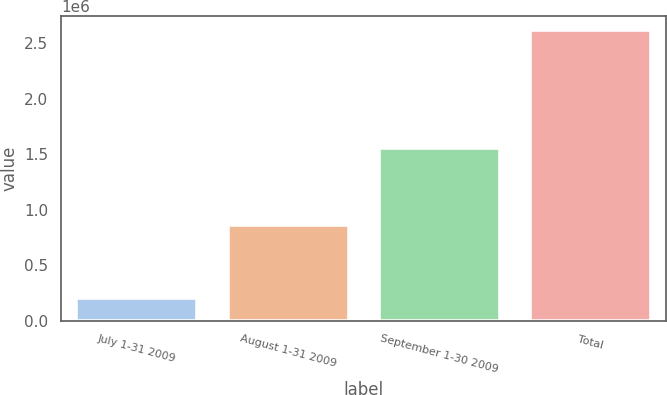<chart> <loc_0><loc_0><loc_500><loc_500><bar_chart><fcel>July 1-31 2009<fcel>August 1-31 2009<fcel>September 1-30 2009<fcel>Total<nl><fcel>200594<fcel>864012<fcel>1.55292e+06<fcel>2.61752e+06<nl></chart> 